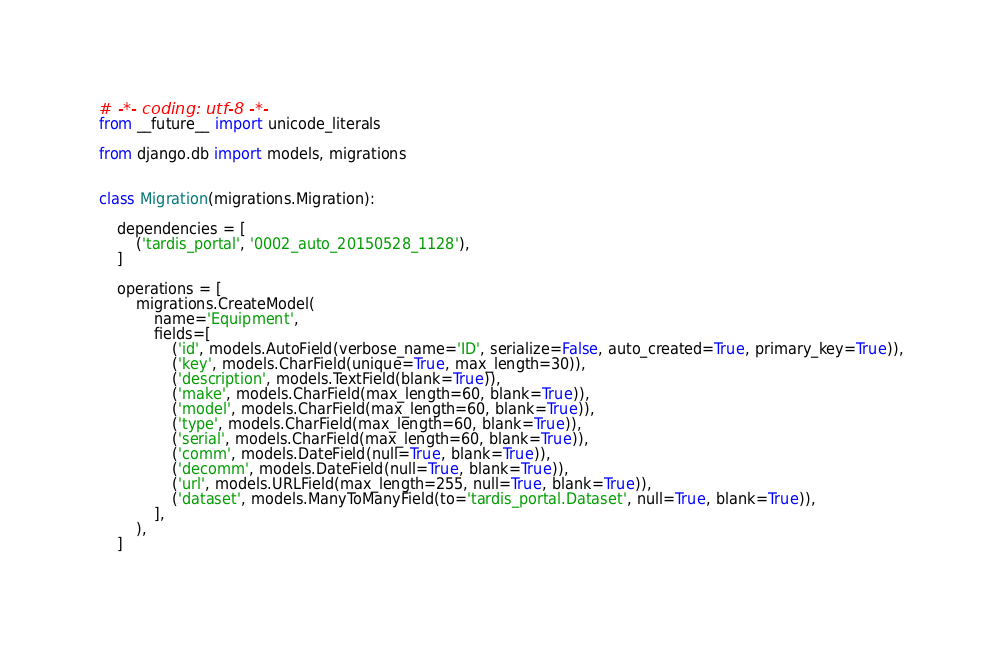<code> <loc_0><loc_0><loc_500><loc_500><_Python_># -*- coding: utf-8 -*-
from __future__ import unicode_literals

from django.db import models, migrations


class Migration(migrations.Migration):

    dependencies = [
        ('tardis_portal', '0002_auto_20150528_1128'),
    ]

    operations = [
        migrations.CreateModel(
            name='Equipment',
            fields=[
                ('id', models.AutoField(verbose_name='ID', serialize=False, auto_created=True, primary_key=True)),
                ('key', models.CharField(unique=True, max_length=30)),
                ('description', models.TextField(blank=True)),
                ('make', models.CharField(max_length=60, blank=True)),
                ('model', models.CharField(max_length=60, blank=True)),
                ('type', models.CharField(max_length=60, blank=True)),
                ('serial', models.CharField(max_length=60, blank=True)),
                ('comm', models.DateField(null=True, blank=True)),
                ('decomm', models.DateField(null=True, blank=True)),
                ('url', models.URLField(max_length=255, null=True, blank=True)),
                ('dataset', models.ManyToManyField(to='tardis_portal.Dataset', null=True, blank=True)),
            ],
        ),
    ]
</code> 